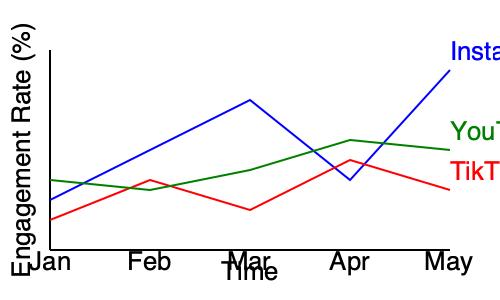Analyzing the engagement rates of Momin Saqib's posts across different platforms, which social media platform showed the highest engagement rate in May, and what was the approximate percentage? To answer this question, we need to follow these steps:

1. Identify the lines representing different social media platforms:
   - Blue line: Instagram
   - Red line: TikTok
   - Green line: YouTube

2. Locate the data points for May (the rightmost points on each line).

3. Compare the vertical positions of these points:
   - Instagram: Highest point, around 18% engagement rate
   - TikTok: Middle point, around 6% engagement rate
   - YouTube: Lowest point, around 5% engagement rate

4. Determine which platform has the highest engagement rate in May:
   Instagram has the highest point, indicating the highest engagement rate.

5. Estimate the approximate percentage for Instagram in May:
   The y-axis represents engagement rate percentages. The Instagram data point for May appears to be slightly above the 15% mark, approximately at 18%.

Therefore, Instagram showed the highest engagement rate in May, with an approximate percentage of 18%.
Answer: Instagram, 18% 